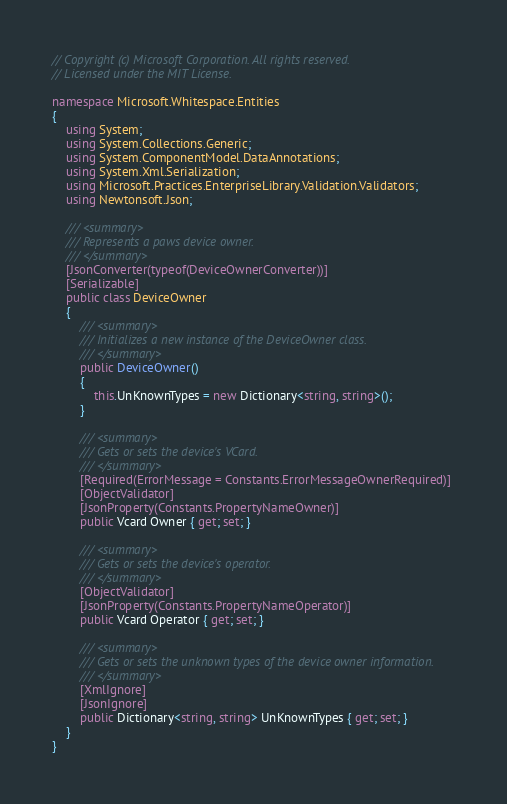Convert code to text. <code><loc_0><loc_0><loc_500><loc_500><_C#_>// Copyright (c) Microsoft Corporation. All rights reserved.
// Licensed under the MIT License.

namespace Microsoft.Whitespace.Entities
{
    using System;
    using System.Collections.Generic;
    using System.ComponentModel.DataAnnotations;
    using System.Xml.Serialization;
    using Microsoft.Practices.EnterpriseLibrary.Validation.Validators;
    using Newtonsoft.Json;

    /// <summary>
    /// Represents a paws device owner.
    /// </summary>
    [JsonConverter(typeof(DeviceOwnerConverter))]
    [Serializable]
    public class DeviceOwner
    {
        /// <summary>
        /// Initializes a new instance of the DeviceOwner class.
        /// </summary>
        public DeviceOwner()
        {
            this.UnKnownTypes = new Dictionary<string, string>();
        }

        /// <summary>
        /// Gets or sets the device's VCard.
        /// </summary>
        [Required(ErrorMessage = Constants.ErrorMessageOwnerRequired)]
        [ObjectValidator]
        [JsonProperty(Constants.PropertyNameOwner)]
        public Vcard Owner { get; set; }

        /// <summary>
        /// Gets or sets the device's operator.
        /// </summary>
        [ObjectValidator]
        [JsonProperty(Constants.PropertyNameOperator)]
        public Vcard Operator { get; set; }

        /// <summary>
        /// Gets or sets the unknown types of the device owner information.
        /// </summary>
        [XmlIgnore]
        [JsonIgnore]
        public Dictionary<string, string> UnKnownTypes { get; set; }
    }
}
</code> 